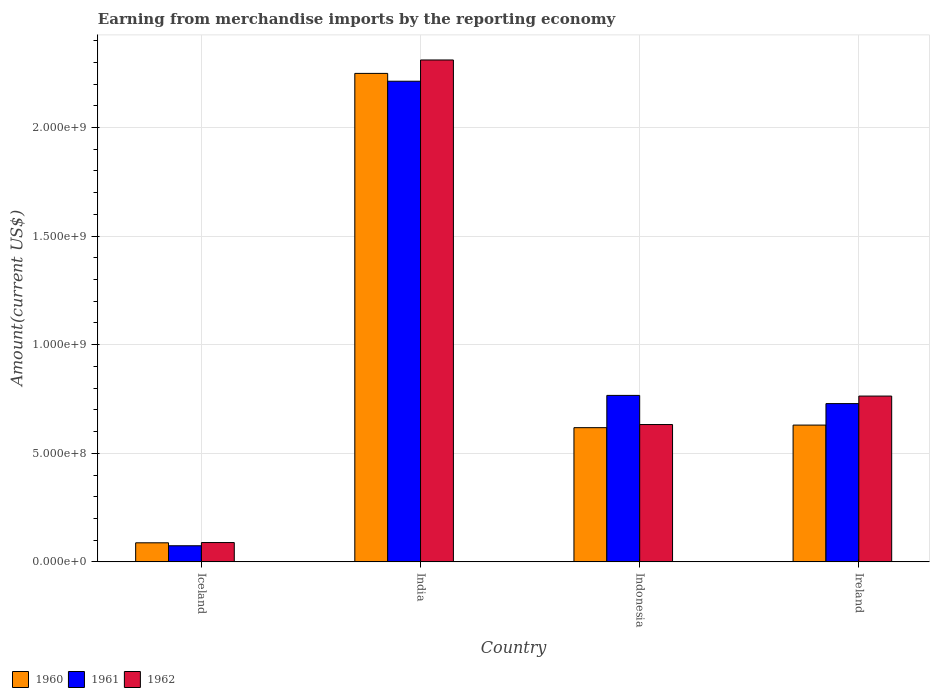How many different coloured bars are there?
Offer a very short reply. 3. Are the number of bars per tick equal to the number of legend labels?
Ensure brevity in your answer.  Yes. Are the number of bars on each tick of the X-axis equal?
Provide a succinct answer. Yes. How many bars are there on the 4th tick from the left?
Your answer should be very brief. 3. What is the label of the 1st group of bars from the left?
Your answer should be compact. Iceland. In how many cases, is the number of bars for a given country not equal to the number of legend labels?
Provide a short and direct response. 0. What is the amount earned from merchandise imports in 1961 in Indonesia?
Your answer should be very brief. 7.67e+08. Across all countries, what is the maximum amount earned from merchandise imports in 1961?
Offer a terse response. 2.21e+09. Across all countries, what is the minimum amount earned from merchandise imports in 1961?
Provide a short and direct response. 7.42e+07. In which country was the amount earned from merchandise imports in 1961 maximum?
Provide a short and direct response. India. In which country was the amount earned from merchandise imports in 1960 minimum?
Make the answer very short. Iceland. What is the total amount earned from merchandise imports in 1960 in the graph?
Your response must be concise. 3.59e+09. What is the difference between the amount earned from merchandise imports in 1962 in Iceland and that in India?
Make the answer very short. -2.22e+09. What is the difference between the amount earned from merchandise imports in 1961 in Iceland and the amount earned from merchandise imports in 1960 in Ireland?
Keep it short and to the point. -5.56e+08. What is the average amount earned from merchandise imports in 1961 per country?
Your answer should be compact. 9.46e+08. What is the difference between the amount earned from merchandise imports of/in 1962 and amount earned from merchandise imports of/in 1961 in India?
Your response must be concise. 9.79e+07. What is the ratio of the amount earned from merchandise imports in 1960 in Indonesia to that in Ireland?
Make the answer very short. 0.98. Is the difference between the amount earned from merchandise imports in 1962 in Indonesia and Ireland greater than the difference between the amount earned from merchandise imports in 1961 in Indonesia and Ireland?
Your answer should be compact. No. What is the difference between the highest and the second highest amount earned from merchandise imports in 1962?
Keep it short and to the point. 1.68e+09. What is the difference between the highest and the lowest amount earned from merchandise imports in 1960?
Make the answer very short. 2.16e+09. What does the 3rd bar from the left in Indonesia represents?
Your response must be concise. 1962. How many countries are there in the graph?
Keep it short and to the point. 4. Does the graph contain grids?
Ensure brevity in your answer.  Yes. Where does the legend appear in the graph?
Keep it short and to the point. Bottom left. How many legend labels are there?
Your response must be concise. 3. How are the legend labels stacked?
Offer a terse response. Horizontal. What is the title of the graph?
Give a very brief answer. Earning from merchandise imports by the reporting economy. What is the label or title of the X-axis?
Provide a succinct answer. Country. What is the label or title of the Y-axis?
Provide a short and direct response. Amount(current US$). What is the Amount(current US$) in 1960 in Iceland?
Provide a succinct answer. 8.78e+07. What is the Amount(current US$) in 1961 in Iceland?
Offer a very short reply. 7.42e+07. What is the Amount(current US$) of 1962 in Iceland?
Offer a terse response. 8.90e+07. What is the Amount(current US$) of 1960 in India?
Give a very brief answer. 2.25e+09. What is the Amount(current US$) of 1961 in India?
Keep it short and to the point. 2.21e+09. What is the Amount(current US$) of 1962 in India?
Your answer should be compact. 2.31e+09. What is the Amount(current US$) in 1960 in Indonesia?
Provide a short and direct response. 6.18e+08. What is the Amount(current US$) of 1961 in Indonesia?
Give a very brief answer. 7.67e+08. What is the Amount(current US$) of 1962 in Indonesia?
Your response must be concise. 6.32e+08. What is the Amount(current US$) in 1960 in Ireland?
Offer a very short reply. 6.30e+08. What is the Amount(current US$) of 1961 in Ireland?
Give a very brief answer. 7.29e+08. What is the Amount(current US$) of 1962 in Ireland?
Make the answer very short. 7.64e+08. Across all countries, what is the maximum Amount(current US$) in 1960?
Provide a short and direct response. 2.25e+09. Across all countries, what is the maximum Amount(current US$) of 1961?
Provide a succinct answer. 2.21e+09. Across all countries, what is the maximum Amount(current US$) in 1962?
Offer a terse response. 2.31e+09. Across all countries, what is the minimum Amount(current US$) of 1960?
Give a very brief answer. 8.78e+07. Across all countries, what is the minimum Amount(current US$) of 1961?
Keep it short and to the point. 7.42e+07. Across all countries, what is the minimum Amount(current US$) in 1962?
Offer a very short reply. 8.90e+07. What is the total Amount(current US$) of 1960 in the graph?
Offer a very short reply. 3.59e+09. What is the total Amount(current US$) in 1961 in the graph?
Your answer should be compact. 3.78e+09. What is the total Amount(current US$) in 1962 in the graph?
Give a very brief answer. 3.80e+09. What is the difference between the Amount(current US$) of 1960 in Iceland and that in India?
Provide a short and direct response. -2.16e+09. What is the difference between the Amount(current US$) of 1961 in Iceland and that in India?
Ensure brevity in your answer.  -2.14e+09. What is the difference between the Amount(current US$) of 1962 in Iceland and that in India?
Make the answer very short. -2.22e+09. What is the difference between the Amount(current US$) of 1960 in Iceland and that in Indonesia?
Provide a short and direct response. -5.30e+08. What is the difference between the Amount(current US$) of 1961 in Iceland and that in Indonesia?
Provide a short and direct response. -6.92e+08. What is the difference between the Amount(current US$) in 1962 in Iceland and that in Indonesia?
Provide a succinct answer. -5.43e+08. What is the difference between the Amount(current US$) of 1960 in Iceland and that in Ireland?
Provide a succinct answer. -5.42e+08. What is the difference between the Amount(current US$) of 1961 in Iceland and that in Ireland?
Your answer should be very brief. -6.55e+08. What is the difference between the Amount(current US$) in 1962 in Iceland and that in Ireland?
Keep it short and to the point. -6.74e+08. What is the difference between the Amount(current US$) in 1960 in India and that in Indonesia?
Keep it short and to the point. 1.63e+09. What is the difference between the Amount(current US$) in 1961 in India and that in Indonesia?
Your answer should be very brief. 1.45e+09. What is the difference between the Amount(current US$) in 1962 in India and that in Indonesia?
Make the answer very short. 1.68e+09. What is the difference between the Amount(current US$) in 1960 in India and that in Ireland?
Offer a very short reply. 1.62e+09. What is the difference between the Amount(current US$) in 1961 in India and that in Ireland?
Provide a short and direct response. 1.48e+09. What is the difference between the Amount(current US$) of 1962 in India and that in Ireland?
Offer a terse response. 1.55e+09. What is the difference between the Amount(current US$) in 1960 in Indonesia and that in Ireland?
Your answer should be compact. -1.19e+07. What is the difference between the Amount(current US$) in 1961 in Indonesia and that in Ireland?
Provide a short and direct response. 3.78e+07. What is the difference between the Amount(current US$) in 1962 in Indonesia and that in Ireland?
Keep it short and to the point. -1.31e+08. What is the difference between the Amount(current US$) in 1960 in Iceland and the Amount(current US$) in 1961 in India?
Offer a terse response. -2.13e+09. What is the difference between the Amount(current US$) in 1960 in Iceland and the Amount(current US$) in 1962 in India?
Ensure brevity in your answer.  -2.22e+09. What is the difference between the Amount(current US$) in 1961 in Iceland and the Amount(current US$) in 1962 in India?
Offer a terse response. -2.24e+09. What is the difference between the Amount(current US$) in 1960 in Iceland and the Amount(current US$) in 1961 in Indonesia?
Make the answer very short. -6.79e+08. What is the difference between the Amount(current US$) in 1960 in Iceland and the Amount(current US$) in 1962 in Indonesia?
Provide a succinct answer. -5.45e+08. What is the difference between the Amount(current US$) of 1961 in Iceland and the Amount(current US$) of 1962 in Indonesia?
Ensure brevity in your answer.  -5.58e+08. What is the difference between the Amount(current US$) in 1960 in Iceland and the Amount(current US$) in 1961 in Ireland?
Your response must be concise. -6.41e+08. What is the difference between the Amount(current US$) of 1960 in Iceland and the Amount(current US$) of 1962 in Ireland?
Give a very brief answer. -6.76e+08. What is the difference between the Amount(current US$) of 1961 in Iceland and the Amount(current US$) of 1962 in Ireland?
Ensure brevity in your answer.  -6.89e+08. What is the difference between the Amount(current US$) in 1960 in India and the Amount(current US$) in 1961 in Indonesia?
Provide a short and direct response. 1.48e+09. What is the difference between the Amount(current US$) in 1960 in India and the Amount(current US$) in 1962 in Indonesia?
Offer a very short reply. 1.62e+09. What is the difference between the Amount(current US$) in 1961 in India and the Amount(current US$) in 1962 in Indonesia?
Your response must be concise. 1.58e+09. What is the difference between the Amount(current US$) of 1960 in India and the Amount(current US$) of 1961 in Ireland?
Provide a succinct answer. 1.52e+09. What is the difference between the Amount(current US$) in 1960 in India and the Amount(current US$) in 1962 in Ireland?
Your answer should be very brief. 1.49e+09. What is the difference between the Amount(current US$) of 1961 in India and the Amount(current US$) of 1962 in Ireland?
Make the answer very short. 1.45e+09. What is the difference between the Amount(current US$) of 1960 in Indonesia and the Amount(current US$) of 1961 in Ireland?
Provide a short and direct response. -1.11e+08. What is the difference between the Amount(current US$) in 1960 in Indonesia and the Amount(current US$) in 1962 in Ireland?
Give a very brief answer. -1.46e+08. What is the difference between the Amount(current US$) of 1961 in Indonesia and the Amount(current US$) of 1962 in Ireland?
Make the answer very short. 3.10e+06. What is the average Amount(current US$) in 1960 per country?
Provide a succinct answer. 8.96e+08. What is the average Amount(current US$) of 1961 per country?
Keep it short and to the point. 9.46e+08. What is the average Amount(current US$) of 1962 per country?
Ensure brevity in your answer.  9.49e+08. What is the difference between the Amount(current US$) of 1960 and Amount(current US$) of 1961 in Iceland?
Your answer should be very brief. 1.36e+07. What is the difference between the Amount(current US$) in 1960 and Amount(current US$) in 1962 in Iceland?
Make the answer very short. -1.20e+06. What is the difference between the Amount(current US$) of 1961 and Amount(current US$) of 1962 in Iceland?
Offer a terse response. -1.48e+07. What is the difference between the Amount(current US$) in 1960 and Amount(current US$) in 1961 in India?
Your answer should be very brief. 3.61e+07. What is the difference between the Amount(current US$) in 1960 and Amount(current US$) in 1962 in India?
Give a very brief answer. -6.18e+07. What is the difference between the Amount(current US$) of 1961 and Amount(current US$) of 1962 in India?
Your response must be concise. -9.79e+07. What is the difference between the Amount(current US$) of 1960 and Amount(current US$) of 1961 in Indonesia?
Provide a succinct answer. -1.49e+08. What is the difference between the Amount(current US$) of 1960 and Amount(current US$) of 1962 in Indonesia?
Keep it short and to the point. -1.44e+07. What is the difference between the Amount(current US$) in 1961 and Amount(current US$) in 1962 in Indonesia?
Provide a succinct answer. 1.34e+08. What is the difference between the Amount(current US$) of 1960 and Amount(current US$) of 1961 in Ireland?
Your response must be concise. -9.89e+07. What is the difference between the Amount(current US$) of 1960 and Amount(current US$) of 1962 in Ireland?
Provide a short and direct response. -1.34e+08. What is the difference between the Amount(current US$) of 1961 and Amount(current US$) of 1962 in Ireland?
Your answer should be compact. -3.47e+07. What is the ratio of the Amount(current US$) in 1960 in Iceland to that in India?
Keep it short and to the point. 0.04. What is the ratio of the Amount(current US$) of 1961 in Iceland to that in India?
Your answer should be very brief. 0.03. What is the ratio of the Amount(current US$) in 1962 in Iceland to that in India?
Give a very brief answer. 0.04. What is the ratio of the Amount(current US$) of 1960 in Iceland to that in Indonesia?
Give a very brief answer. 0.14. What is the ratio of the Amount(current US$) of 1961 in Iceland to that in Indonesia?
Your answer should be very brief. 0.1. What is the ratio of the Amount(current US$) of 1962 in Iceland to that in Indonesia?
Provide a succinct answer. 0.14. What is the ratio of the Amount(current US$) of 1960 in Iceland to that in Ireland?
Offer a terse response. 0.14. What is the ratio of the Amount(current US$) of 1961 in Iceland to that in Ireland?
Offer a very short reply. 0.1. What is the ratio of the Amount(current US$) of 1962 in Iceland to that in Ireland?
Provide a succinct answer. 0.12. What is the ratio of the Amount(current US$) of 1960 in India to that in Indonesia?
Your answer should be very brief. 3.64. What is the ratio of the Amount(current US$) of 1961 in India to that in Indonesia?
Your response must be concise. 2.89. What is the ratio of the Amount(current US$) in 1962 in India to that in Indonesia?
Offer a terse response. 3.65. What is the ratio of the Amount(current US$) of 1960 in India to that in Ireland?
Offer a very short reply. 3.57. What is the ratio of the Amount(current US$) in 1961 in India to that in Ireland?
Keep it short and to the point. 3.04. What is the ratio of the Amount(current US$) in 1962 in India to that in Ireland?
Keep it short and to the point. 3.03. What is the ratio of the Amount(current US$) of 1960 in Indonesia to that in Ireland?
Offer a very short reply. 0.98. What is the ratio of the Amount(current US$) in 1961 in Indonesia to that in Ireland?
Give a very brief answer. 1.05. What is the ratio of the Amount(current US$) in 1962 in Indonesia to that in Ireland?
Make the answer very short. 0.83. What is the difference between the highest and the second highest Amount(current US$) of 1960?
Offer a very short reply. 1.62e+09. What is the difference between the highest and the second highest Amount(current US$) in 1961?
Ensure brevity in your answer.  1.45e+09. What is the difference between the highest and the second highest Amount(current US$) of 1962?
Give a very brief answer. 1.55e+09. What is the difference between the highest and the lowest Amount(current US$) in 1960?
Your response must be concise. 2.16e+09. What is the difference between the highest and the lowest Amount(current US$) of 1961?
Offer a very short reply. 2.14e+09. What is the difference between the highest and the lowest Amount(current US$) of 1962?
Your answer should be compact. 2.22e+09. 